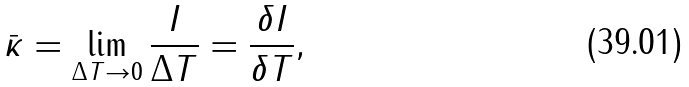Convert formula to latex. <formula><loc_0><loc_0><loc_500><loc_500>\bar { \kappa } = \lim _ { \Delta T \to 0 } \frac { I } { \Delta T } = \frac { \delta I } { \delta T } ,</formula> 